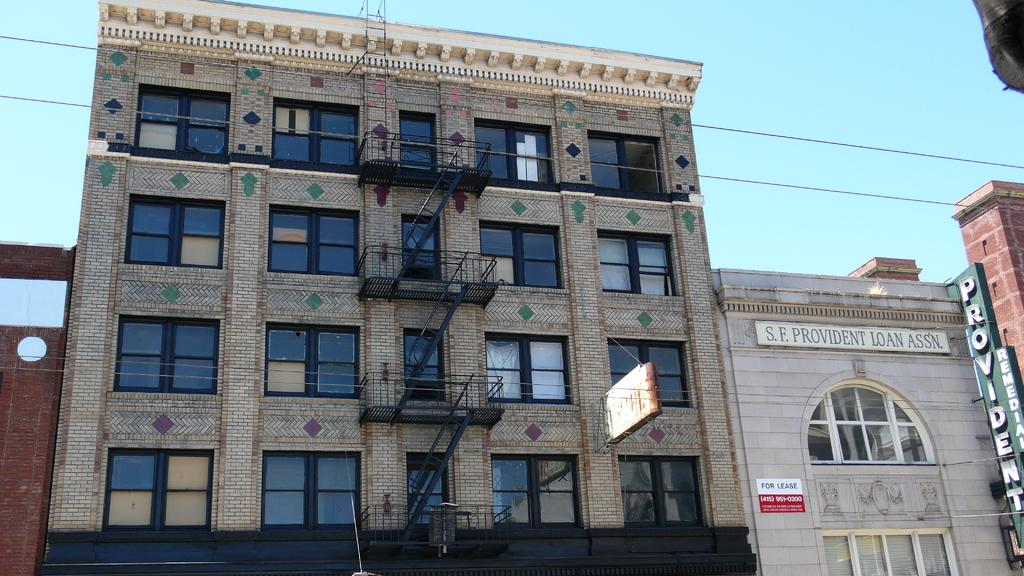What type of structures can be seen in the image? There are buildings in the image. What is attached to the buildings? Boards with text are attached to the buildings. What is visible at the top of the image? The sky is visible at the top of the image. Can you tell me how many goldfish are swimming in the bath in the image? There are no goldfish or bath present in the image; it features buildings with boards attached to them. 